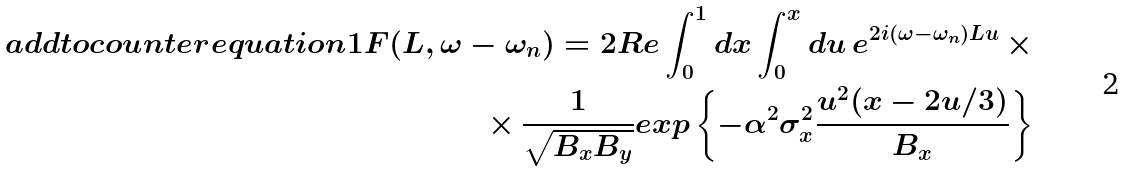Convert formula to latex. <formula><loc_0><loc_0><loc_500><loc_500>\ a d d t o c o u n t e r { e q u a t i o n } { 1 } F ( L , \omega - \omega _ { n } ) = 2 R e \int _ { 0 } ^ { 1 } d x \int _ { 0 } ^ { x } d u \, e ^ { 2 i ( \omega - \omega _ { n } ) L u } \, \times \\ \times \, \frac { 1 } { \sqrt { B _ { x } B _ { y } } } e x p \left \{ - \alpha ^ { 2 } \sigma _ { x } ^ { 2 } \frac { u ^ { 2 } ( x - 2 u / 3 ) } { B _ { x } } \right \}</formula> 